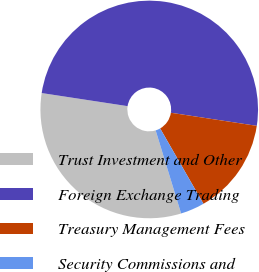Convert chart. <chart><loc_0><loc_0><loc_500><loc_500><pie_chart><fcel>Trust Investment and Other<fcel>Foreign Exchange Trading<fcel>Treasury Management Fees<fcel>Security Commissions and<nl><fcel>32.14%<fcel>50.0%<fcel>14.29%<fcel>3.57%<nl></chart> 